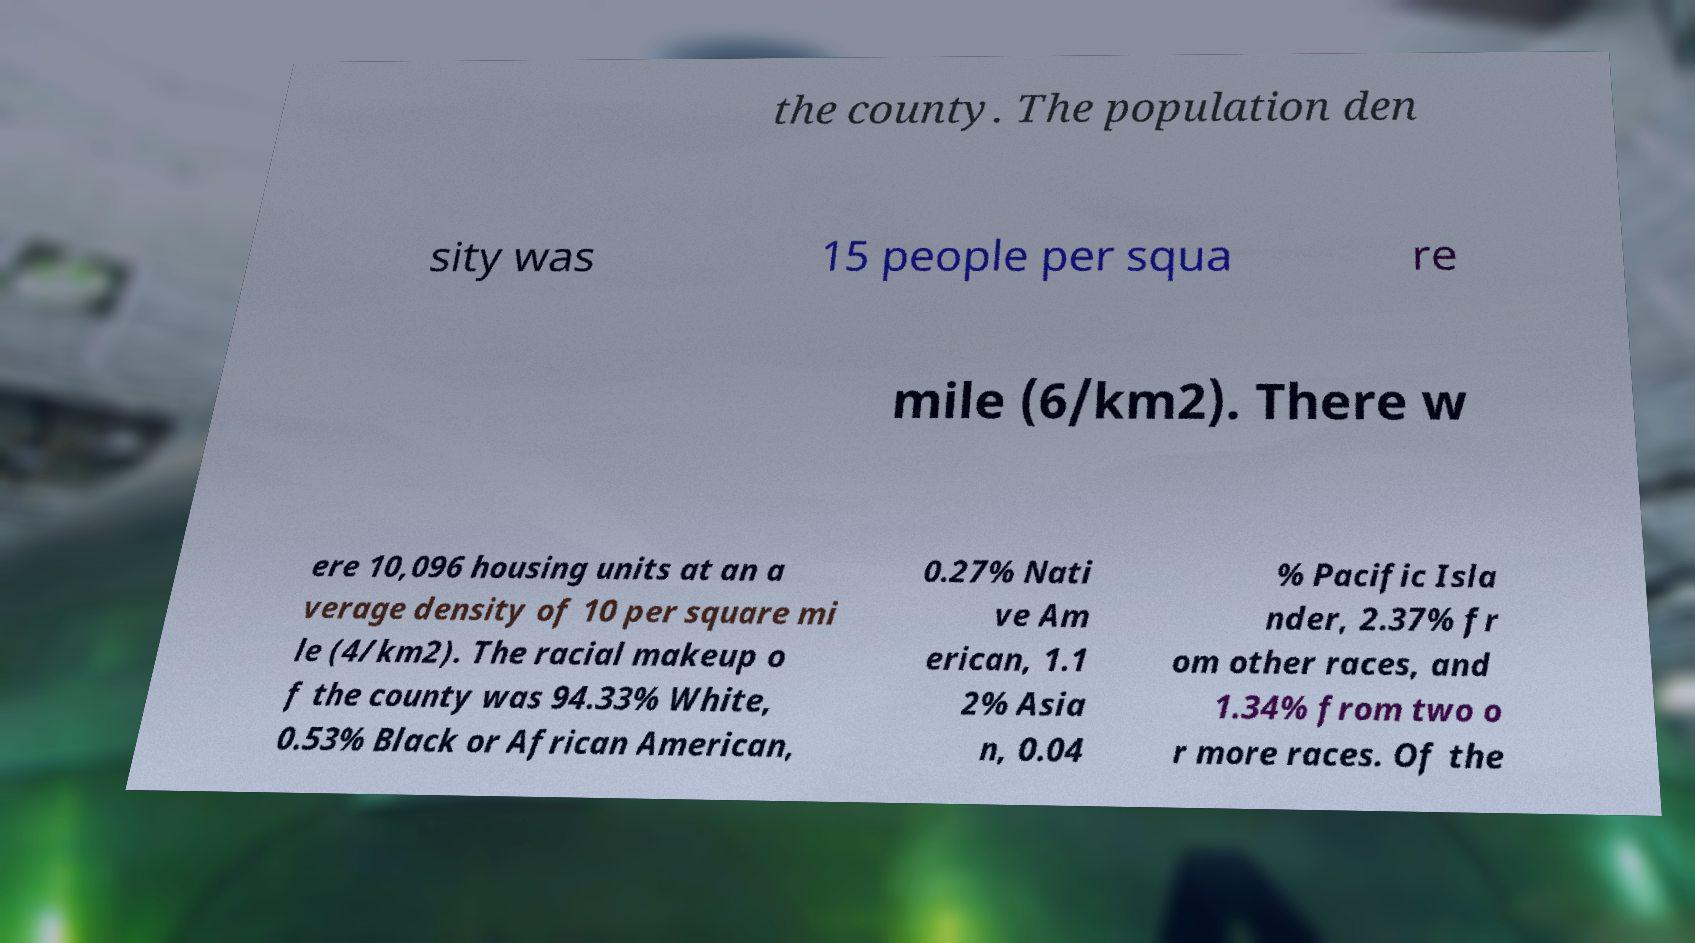Could you extract and type out the text from this image? the county. The population den sity was 15 people per squa re mile (6/km2). There w ere 10,096 housing units at an a verage density of 10 per square mi le (4/km2). The racial makeup o f the county was 94.33% White, 0.53% Black or African American, 0.27% Nati ve Am erican, 1.1 2% Asia n, 0.04 % Pacific Isla nder, 2.37% fr om other races, and 1.34% from two o r more races. Of the 